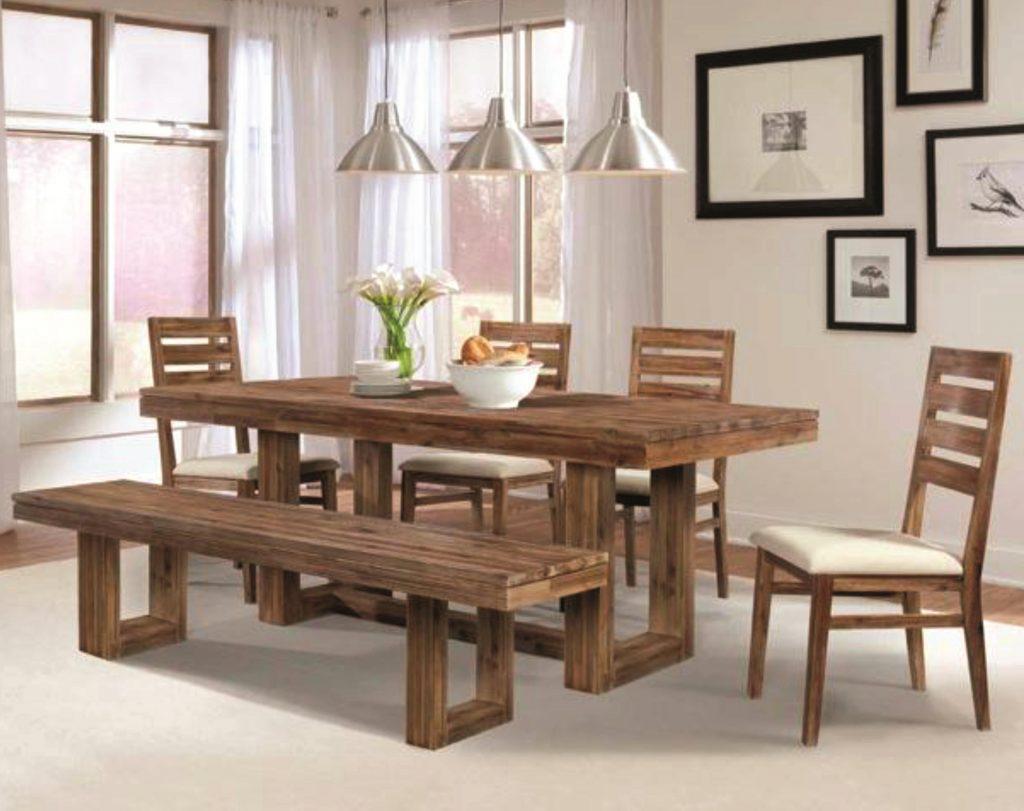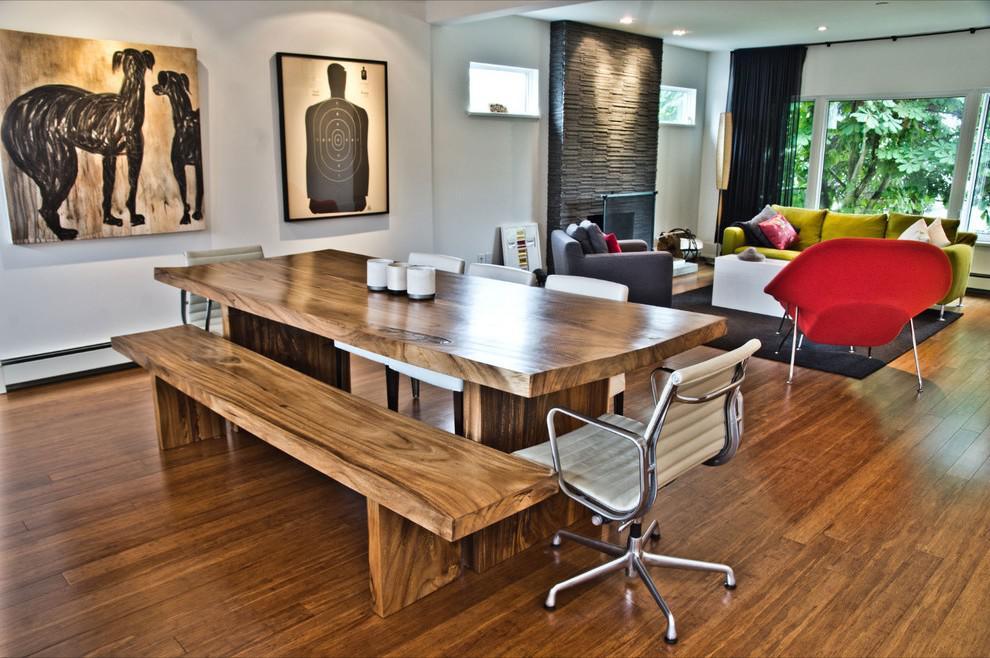The first image is the image on the left, the second image is the image on the right. Analyze the images presented: Is the assertion "there is a wooden dining table with a bench as one of the seats with 3 pendent lights above the table" valid? Answer yes or no. Yes. 